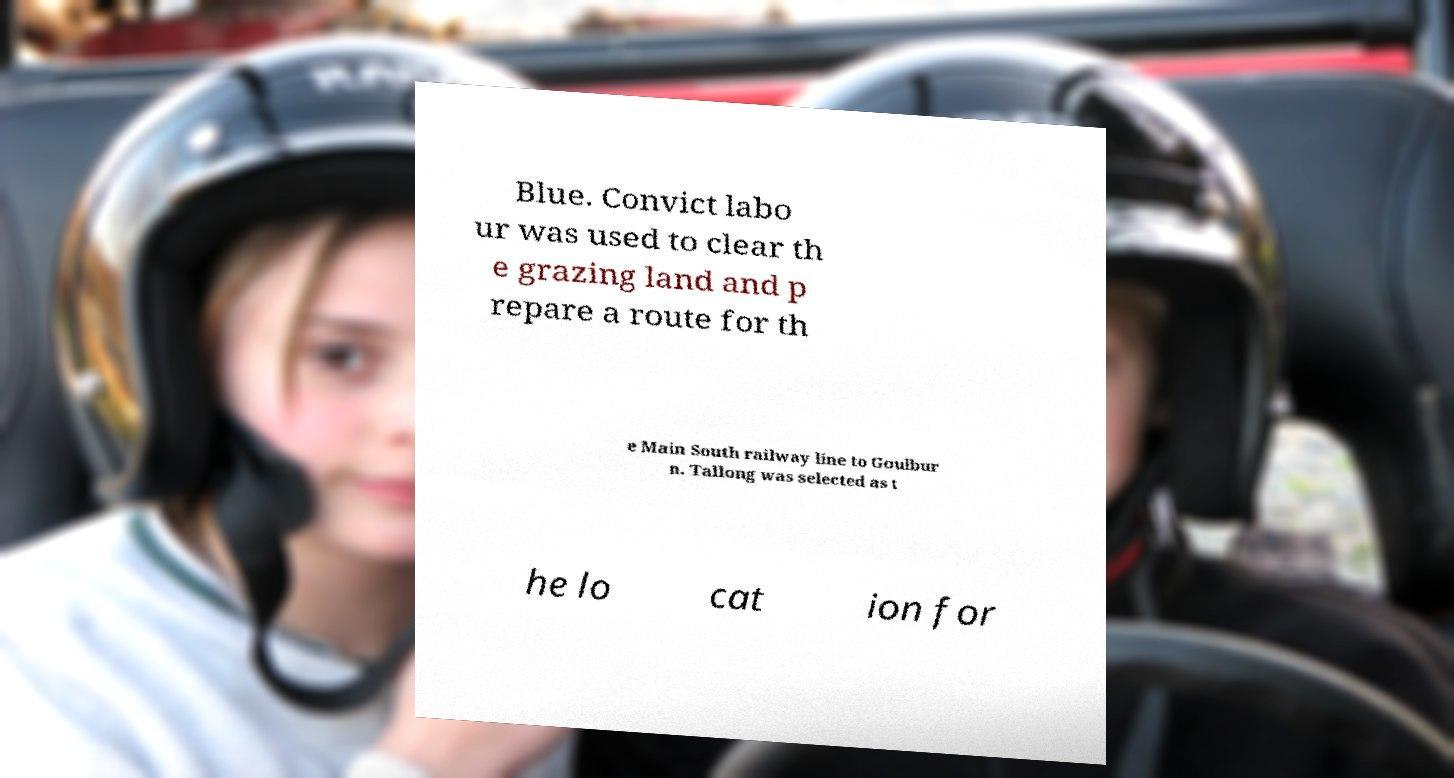For documentation purposes, I need the text within this image transcribed. Could you provide that? Blue. Convict labo ur was used to clear th e grazing land and p repare a route for th e Main South railway line to Goulbur n. Tallong was selected as t he lo cat ion for 